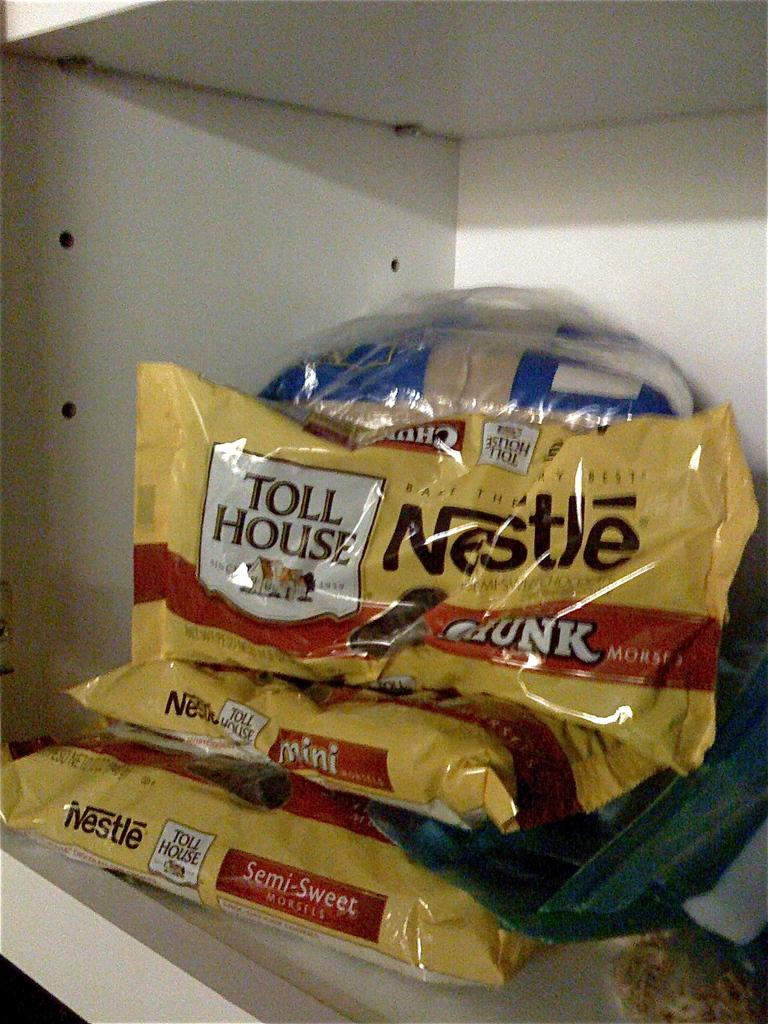What is present on the shelves in the image? There are packets on the shelves in the image. How are the packets arranged or organized on the shelves? The provided facts do not specify the arrangement or organization of the packets on the shelves. Can you hear the band playing quietly in the image? There is no band present in the image, so it is not possible to hear any music or determine the noise level. 